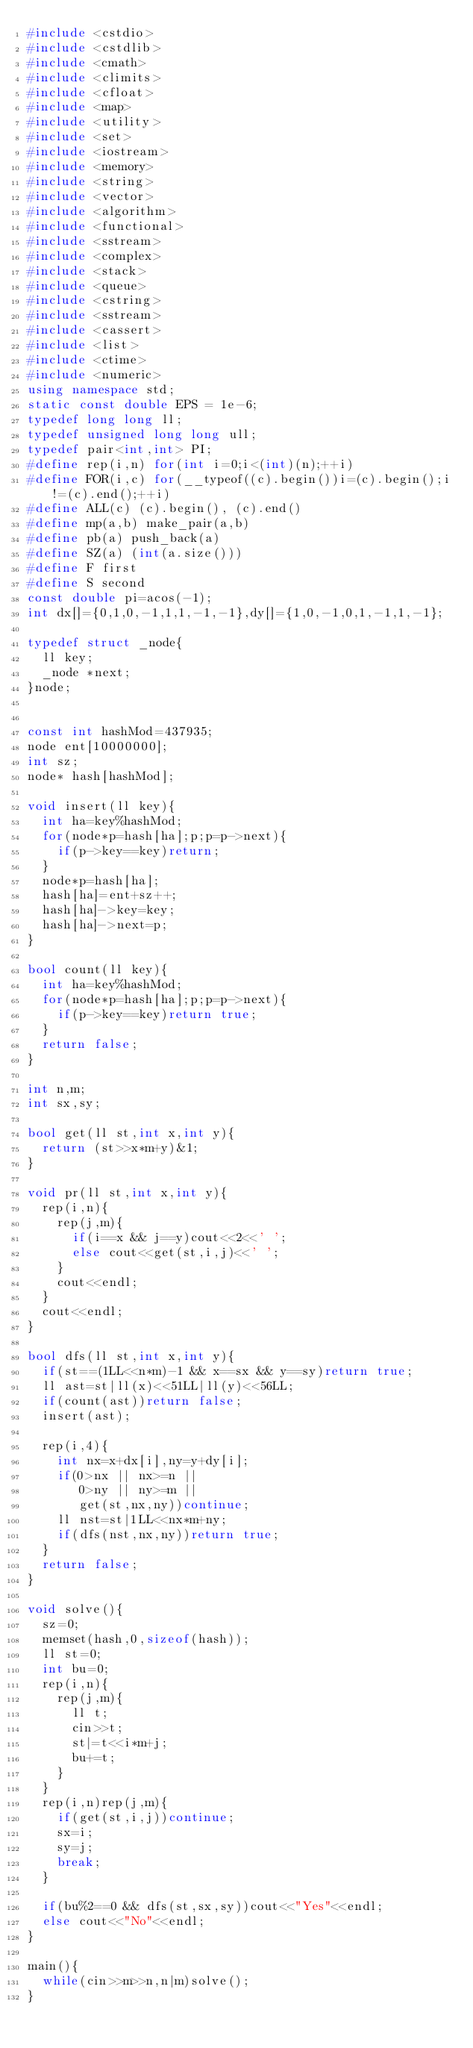<code> <loc_0><loc_0><loc_500><loc_500><_C++_>#include <cstdio>
#include <cstdlib>
#include <cmath>
#include <climits>
#include <cfloat>
#include <map>
#include <utility>
#include <set>
#include <iostream>
#include <memory>
#include <string>
#include <vector>
#include <algorithm>
#include <functional>
#include <sstream>
#include <complex>
#include <stack>
#include <queue>
#include <cstring>
#include <sstream>
#include <cassert>
#include <list>
#include <ctime>
#include <numeric>
using namespace std;
static const double EPS = 1e-6;
typedef long long ll;
typedef unsigned long long ull;
typedef pair<int,int> PI;
#define rep(i,n) for(int i=0;i<(int)(n);++i)
#define FOR(i,c) for(__typeof((c).begin())i=(c).begin();i!=(c).end();++i)
#define ALL(c) (c).begin(), (c).end()
#define mp(a,b) make_pair(a,b)
#define pb(a) push_back(a)
#define SZ(a) (int(a.size()))
#define F first
#define S second
const double pi=acos(-1);
int dx[]={0,1,0,-1,1,1,-1,-1},dy[]={1,0,-1,0,1,-1,1,-1};

typedef struct _node{
  ll key;
  _node *next;
}node;


const int hashMod=437935;
node ent[10000000];
int sz;
node* hash[hashMod];

void insert(ll key){
  int ha=key%hashMod;
  for(node*p=hash[ha];p;p=p->next){
    if(p->key==key)return;
  }
  node*p=hash[ha];
  hash[ha]=ent+sz++;
  hash[ha]->key=key;
  hash[ha]->next=p;
}

bool count(ll key){
  int ha=key%hashMod;
  for(node*p=hash[ha];p;p=p->next){
    if(p->key==key)return true;
  }
  return false;
}

int n,m;
int sx,sy;

bool get(ll st,int x,int y){
  return (st>>x*m+y)&1;
}

void pr(ll st,int x,int y){
  rep(i,n){
    rep(j,m){
      if(i==x && j==y)cout<<2<<' ';
      else cout<<get(st,i,j)<<' ';
    }
    cout<<endl;
  }
  cout<<endl;
}

bool dfs(ll st,int x,int y){
  if(st==(1LL<<n*m)-1 && x==sx && y==sy)return true;
  ll ast=st|ll(x)<<51LL|ll(y)<<56LL;
  if(count(ast))return false;
  insert(ast);

  rep(i,4){
    int nx=x+dx[i],ny=y+dy[i];
    if(0>nx || nx>=n ||
       0>ny || ny>=m ||
       get(st,nx,ny))continue;
    ll nst=st|1LL<<nx*m+ny;
    if(dfs(nst,nx,ny))return true;
  }
  return false;
}

void solve(){
  sz=0;
  memset(hash,0,sizeof(hash));
  ll st=0;
  int bu=0;
  rep(i,n){
    rep(j,m){
      ll t;
      cin>>t;
      st|=t<<i*m+j;
      bu+=t;
    }
  }
  rep(i,n)rep(j,m){
    if(get(st,i,j))continue;
    sx=i;
    sy=j;
    break;
  }
  
  if(bu%2==0 && dfs(st,sx,sy))cout<<"Yes"<<endl;
  else cout<<"No"<<endl;
}

main(){
  while(cin>>m>>n,n|m)solve();
}</code> 